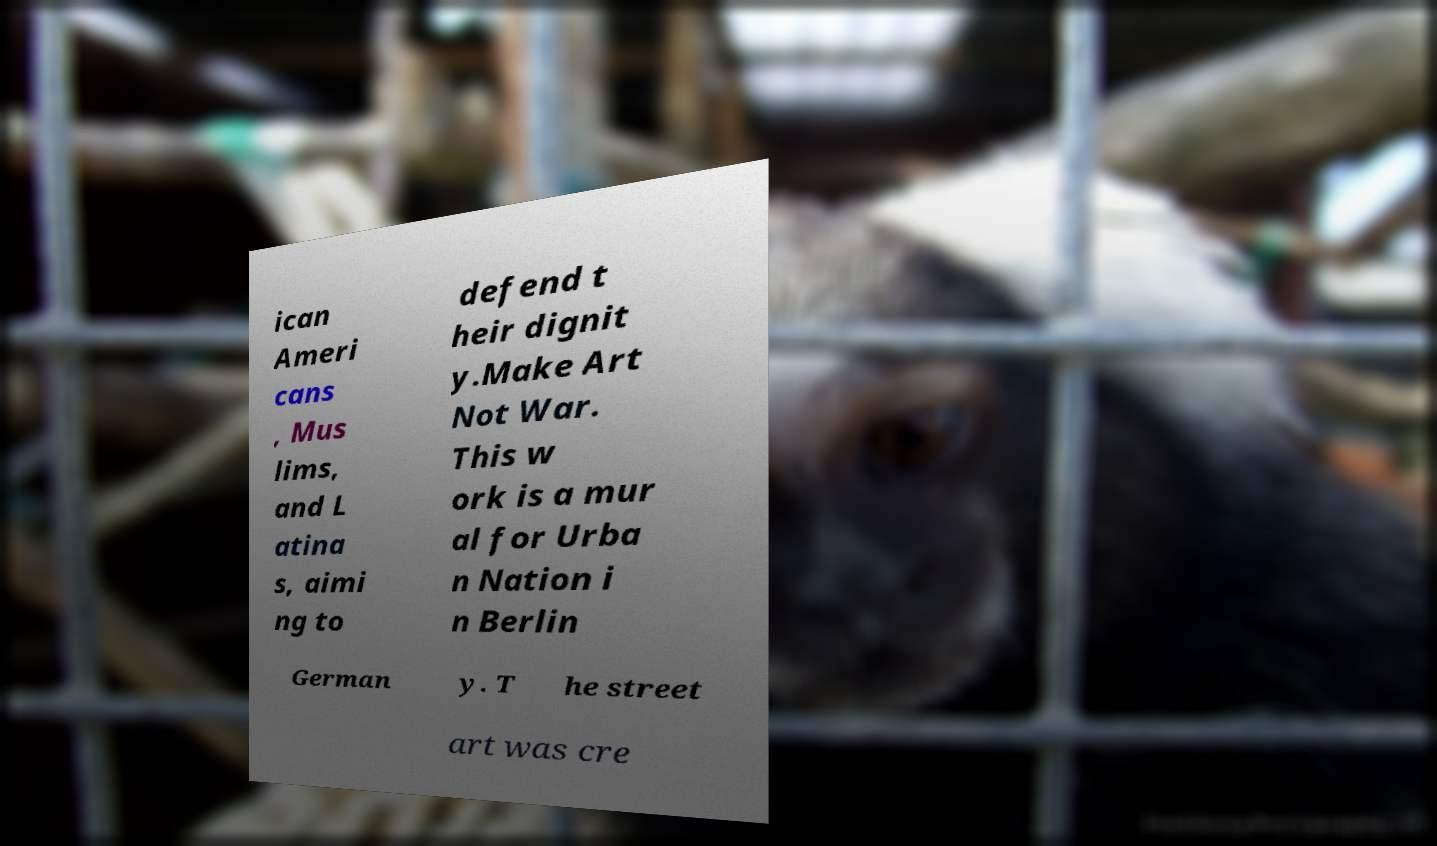For documentation purposes, I need the text within this image transcribed. Could you provide that? ican Ameri cans , Mus lims, and L atina s, aimi ng to defend t heir dignit y.Make Art Not War. This w ork is a mur al for Urba n Nation i n Berlin German y. T he street art was cre 